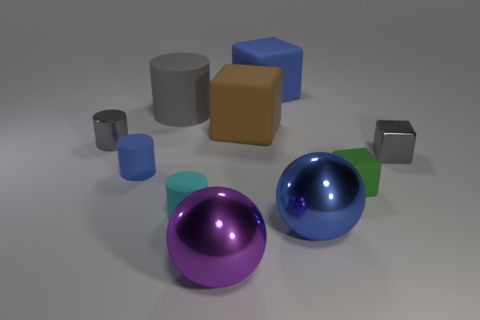What is the size of the rubber cylinder that is the same color as the shiny cube?
Provide a succinct answer. Large. What shape is the metal object that is the same color as the metal cylinder?
Ensure brevity in your answer.  Cube. There is a gray thing to the right of the metallic ball that is in front of the ball to the right of the big blue rubber block; how big is it?
Keep it short and to the point. Small. What is the material of the purple object?
Your response must be concise. Metal. Is the tiny green cube made of the same material as the tiny object that is right of the small matte cube?
Provide a short and direct response. No. Is there any other thing that has the same color as the tiny rubber cube?
Give a very brief answer. No. Is there a blue shiny object behind the blue thing on the left side of the cylinder behind the small metal cylinder?
Make the answer very short. No. What is the color of the big cylinder?
Provide a short and direct response. Gray. Are there any cyan cylinders in front of the metallic cylinder?
Ensure brevity in your answer.  Yes. Do the big purple metal object and the big metal thing on the right side of the brown object have the same shape?
Provide a short and direct response. Yes. 